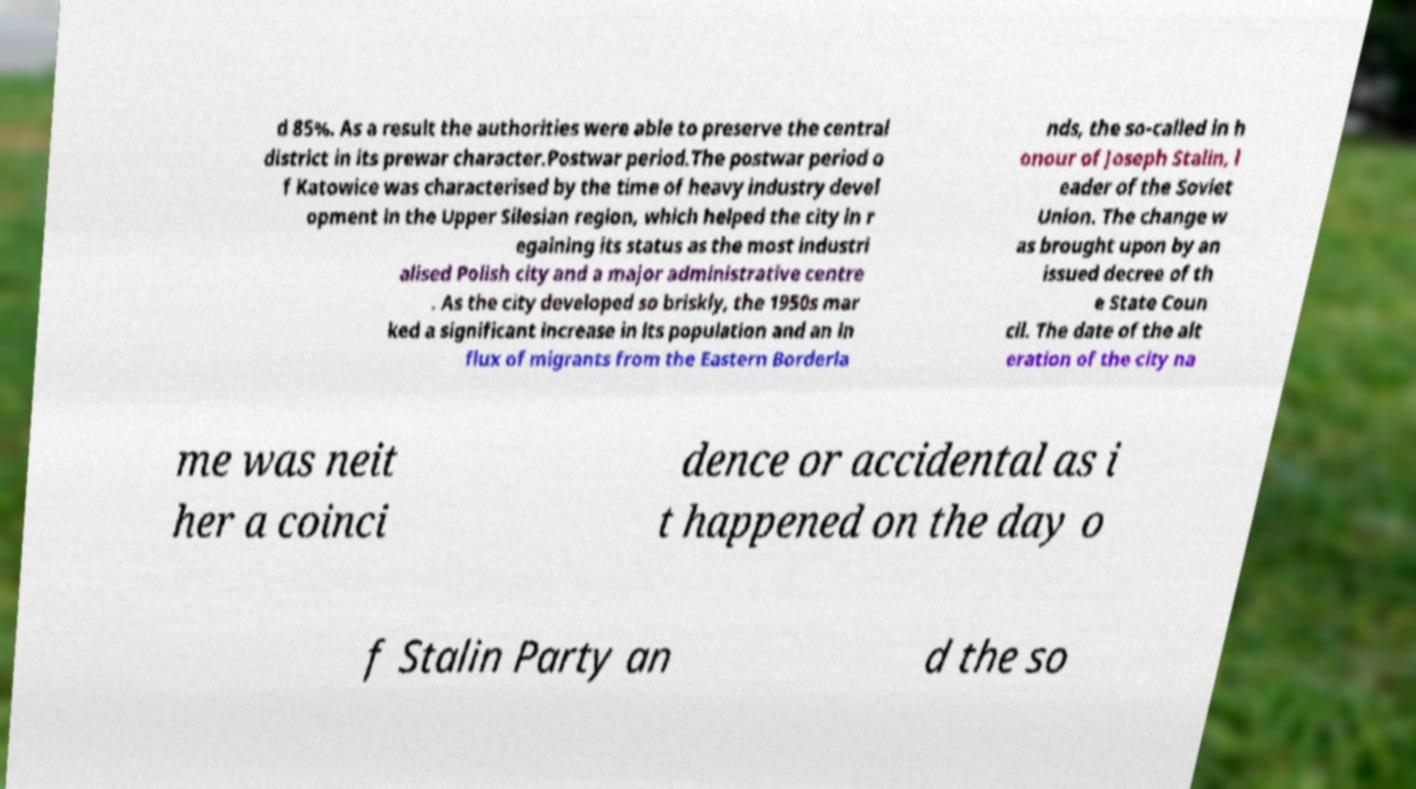What messages or text are displayed in this image? I need them in a readable, typed format. d 85%. As a result the authorities were able to preserve the central district in its prewar character.Postwar period.The postwar period o f Katowice was characterised by the time of heavy industry devel opment in the Upper Silesian region, which helped the city in r egaining its status as the most industri alised Polish city and a major administrative centre . As the city developed so briskly, the 1950s mar ked a significant increase in its population and an in flux of migrants from the Eastern Borderla nds, the so-called in h onour of Joseph Stalin, l eader of the Soviet Union. The change w as brought upon by an issued decree of th e State Coun cil. The date of the alt eration of the city na me was neit her a coinci dence or accidental as i t happened on the day o f Stalin Party an d the so 